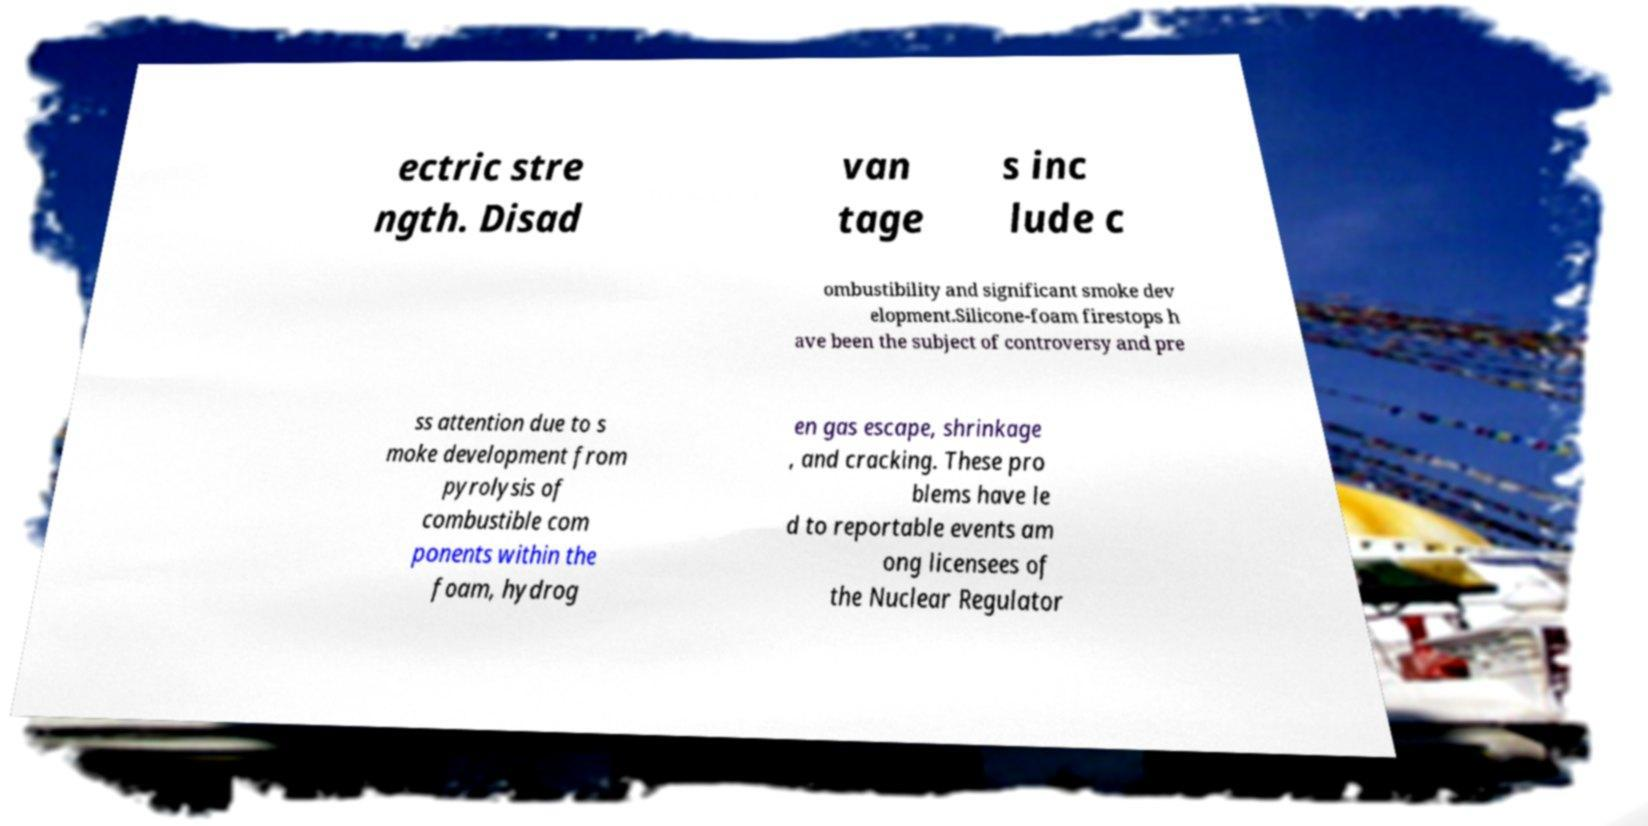Can you accurately transcribe the text from the provided image for me? ectric stre ngth. Disad van tage s inc lude c ombustibility and significant smoke dev elopment.Silicone-foam firestops h ave been the subject of controversy and pre ss attention due to s moke development from pyrolysis of combustible com ponents within the foam, hydrog en gas escape, shrinkage , and cracking. These pro blems have le d to reportable events am ong licensees of the Nuclear Regulator 